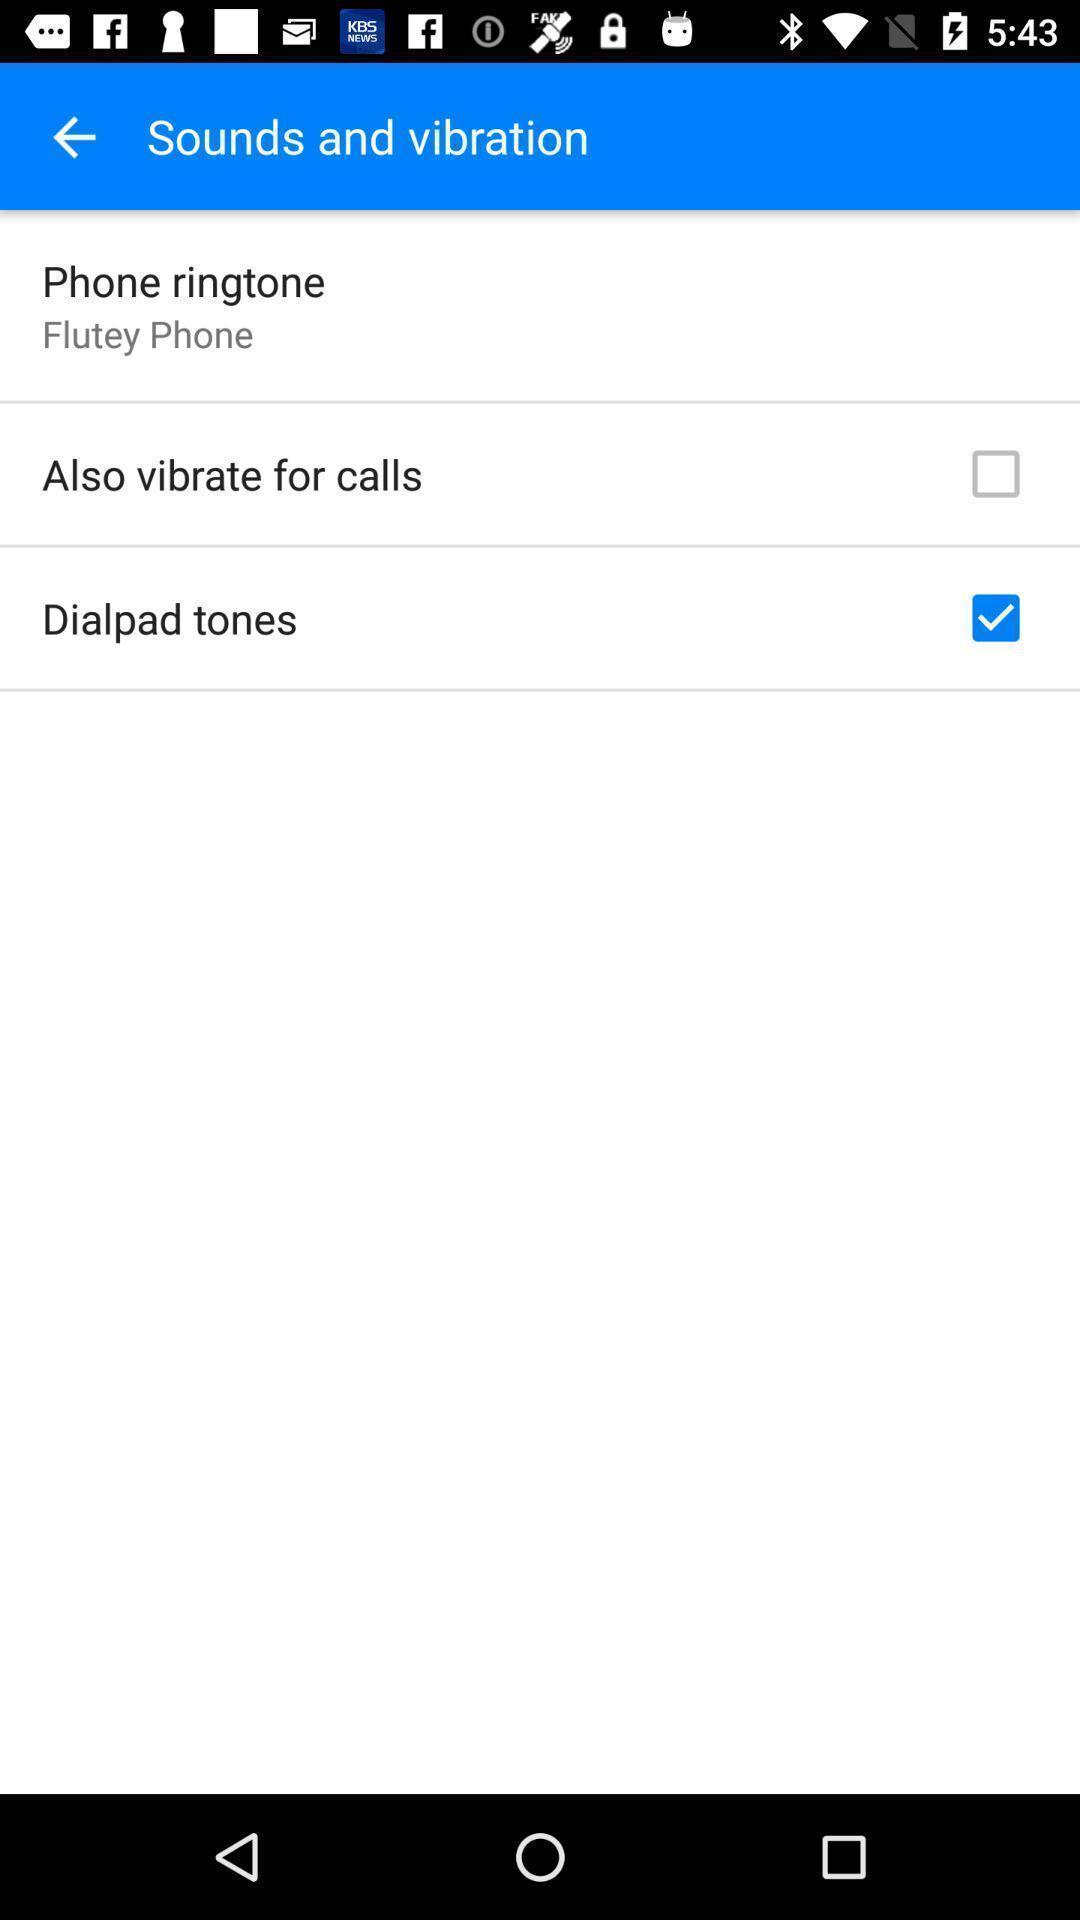Give me a summary of this screen capture. Sounds and vibration settings in settings. 